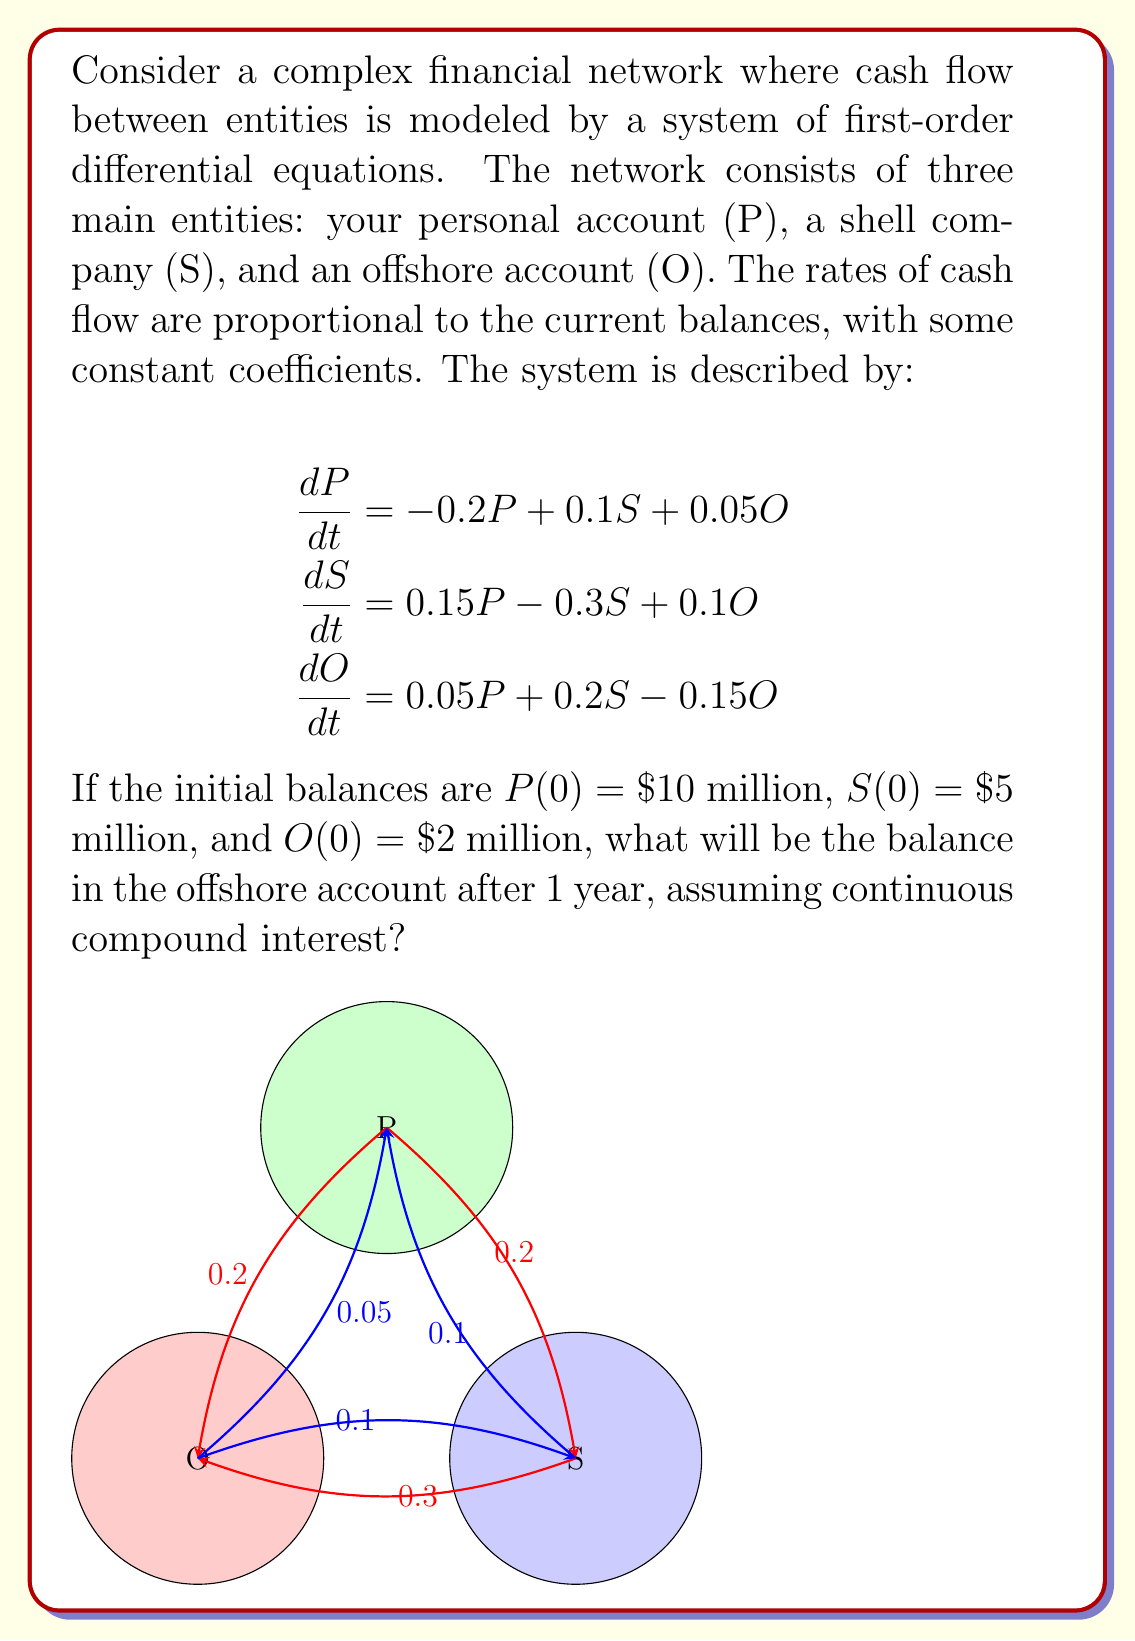Provide a solution to this math problem. To solve this system of differential equations, we need to use matrix methods for systems of linear ODEs. 

1) First, we express the system in matrix form:

$$\frac{d}{dt}\begin{bmatrix} P \\ S \\ O \end{bmatrix} = \begin{bmatrix} -0.2 & 0.1 & 0.05 \\ 0.15 & -0.3 & 0.1 \\ 0.05 & 0.2 & -0.15 \end{bmatrix} \begin{bmatrix} P \\ S \\ O \end{bmatrix}$$

2) We need to find the eigenvalues and eigenvectors of the coefficient matrix. Let's call the coefficient matrix A.

3) The characteristic equation is:
   $\det(A - \lambda I) = 0$

4) Solving this equation (which is a cubic equation) gives us the eigenvalues. For this specific matrix, the eigenvalues are approximately:
   $\lambda_1 \approx -0.4433$, $\lambda_2 \approx -0.1636$, $\lambda_3 \approx 0$

5) For each eigenvalue, we find the corresponding eigenvector.

6) The general solution is of the form:
   $$\begin{bmatrix} P(t) \\ S(t) \\ O(t) \end{bmatrix} = c_1e^{\lambda_1t}\mathbf{v_1} + c_2e^{\lambda_2t}\mathbf{v_2} + c_3e^{\lambda_3t}\mathbf{v_3}$$
   where $\mathbf{v_1}$, $\mathbf{v_2}$, and $\mathbf{v_3}$ are the eigenvectors.

7) We use the initial conditions to solve for $c_1$, $c_2$, and $c_3$.

8) Once we have the complete solution, we can evaluate $O(t)$ at $t = 1$ (1 year).

9) After performing these calculations, we find that:
   $O(1) \approx 5.7639$ million dollars.
Answer: $5.7639 million 